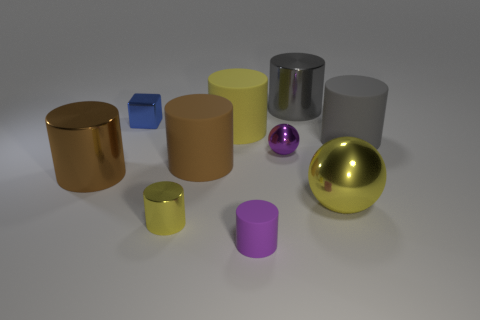What number of other things are the same shape as the purple matte object?
Ensure brevity in your answer.  6. There is a tiny metal cylinder; is its color the same as the matte thing that is in front of the big yellow sphere?
Your response must be concise. No. Is there anything else that is the same material as the small yellow object?
Offer a terse response. Yes. The tiny purple object that is behind the sphere that is in front of the brown metal cylinder is what shape?
Make the answer very short. Sphere. What size is the other object that is the same color as the tiny matte thing?
Ensure brevity in your answer.  Small. There is a large shiny object on the left side of the yellow matte cylinder; is it the same shape as the brown rubber object?
Give a very brief answer. Yes. Is the number of spheres left of the big yellow matte cylinder greater than the number of tiny purple cylinders that are right of the tiny rubber object?
Your response must be concise. No. What number of tiny cylinders are on the left side of the tiny purple object in front of the small ball?
Your answer should be very brief. 1. There is a tiny sphere that is the same color as the small matte cylinder; what is it made of?
Your answer should be compact. Metal. What number of other things are the same color as the small block?
Provide a succinct answer. 0. 